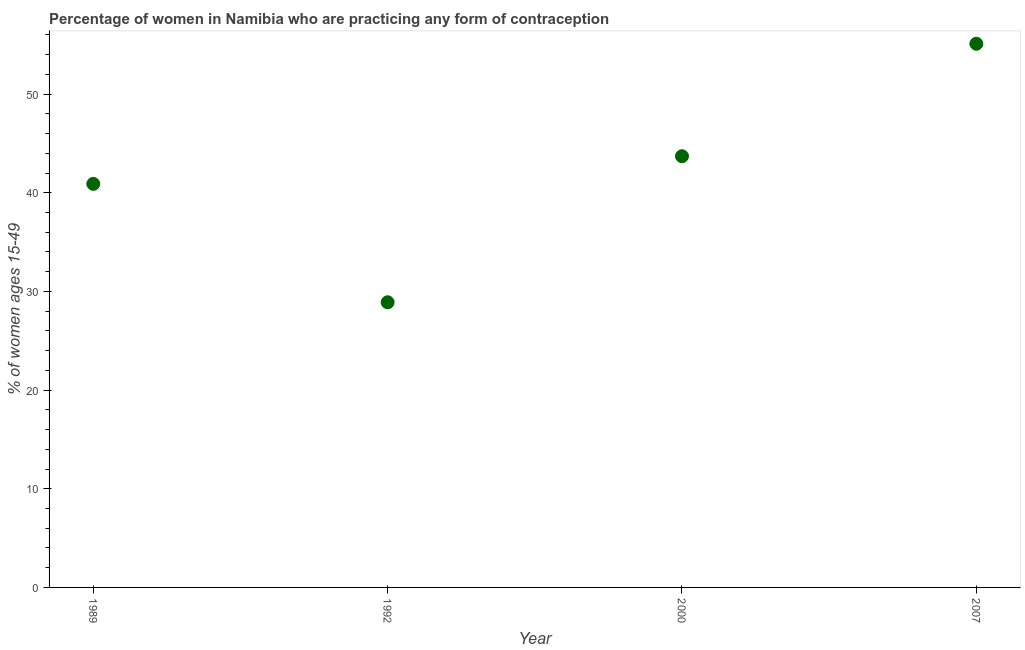What is the contraceptive prevalence in 1992?
Your response must be concise. 28.9. Across all years, what is the maximum contraceptive prevalence?
Your answer should be compact. 55.1. Across all years, what is the minimum contraceptive prevalence?
Make the answer very short. 28.9. In which year was the contraceptive prevalence maximum?
Give a very brief answer. 2007. What is the sum of the contraceptive prevalence?
Offer a very short reply. 168.6. What is the difference between the contraceptive prevalence in 1992 and 2000?
Ensure brevity in your answer.  -14.8. What is the average contraceptive prevalence per year?
Offer a very short reply. 42.15. What is the median contraceptive prevalence?
Keep it short and to the point. 42.3. In how many years, is the contraceptive prevalence greater than 36 %?
Make the answer very short. 3. What is the ratio of the contraceptive prevalence in 2000 to that in 2007?
Give a very brief answer. 0.79. Is the contraceptive prevalence in 1989 less than that in 1992?
Offer a terse response. No. What is the difference between the highest and the second highest contraceptive prevalence?
Keep it short and to the point. 11.4. Is the sum of the contraceptive prevalence in 1992 and 2000 greater than the maximum contraceptive prevalence across all years?
Keep it short and to the point. Yes. What is the difference between the highest and the lowest contraceptive prevalence?
Offer a terse response. 26.2. In how many years, is the contraceptive prevalence greater than the average contraceptive prevalence taken over all years?
Provide a short and direct response. 2. Does the contraceptive prevalence monotonically increase over the years?
Offer a very short reply. No. How many dotlines are there?
Your response must be concise. 1. Are the values on the major ticks of Y-axis written in scientific E-notation?
Provide a succinct answer. No. Does the graph contain any zero values?
Provide a short and direct response. No. Does the graph contain grids?
Your answer should be very brief. No. What is the title of the graph?
Offer a very short reply. Percentage of women in Namibia who are practicing any form of contraception. What is the label or title of the X-axis?
Give a very brief answer. Year. What is the label or title of the Y-axis?
Offer a terse response. % of women ages 15-49. What is the % of women ages 15-49 in 1989?
Offer a very short reply. 40.9. What is the % of women ages 15-49 in 1992?
Provide a short and direct response. 28.9. What is the % of women ages 15-49 in 2000?
Give a very brief answer. 43.7. What is the % of women ages 15-49 in 2007?
Offer a very short reply. 55.1. What is the difference between the % of women ages 15-49 in 1989 and 2000?
Make the answer very short. -2.8. What is the difference between the % of women ages 15-49 in 1989 and 2007?
Make the answer very short. -14.2. What is the difference between the % of women ages 15-49 in 1992 and 2000?
Your answer should be very brief. -14.8. What is the difference between the % of women ages 15-49 in 1992 and 2007?
Offer a very short reply. -26.2. What is the difference between the % of women ages 15-49 in 2000 and 2007?
Provide a short and direct response. -11.4. What is the ratio of the % of women ages 15-49 in 1989 to that in 1992?
Give a very brief answer. 1.42. What is the ratio of the % of women ages 15-49 in 1989 to that in 2000?
Make the answer very short. 0.94. What is the ratio of the % of women ages 15-49 in 1989 to that in 2007?
Provide a short and direct response. 0.74. What is the ratio of the % of women ages 15-49 in 1992 to that in 2000?
Your answer should be compact. 0.66. What is the ratio of the % of women ages 15-49 in 1992 to that in 2007?
Your response must be concise. 0.53. What is the ratio of the % of women ages 15-49 in 2000 to that in 2007?
Your answer should be compact. 0.79. 